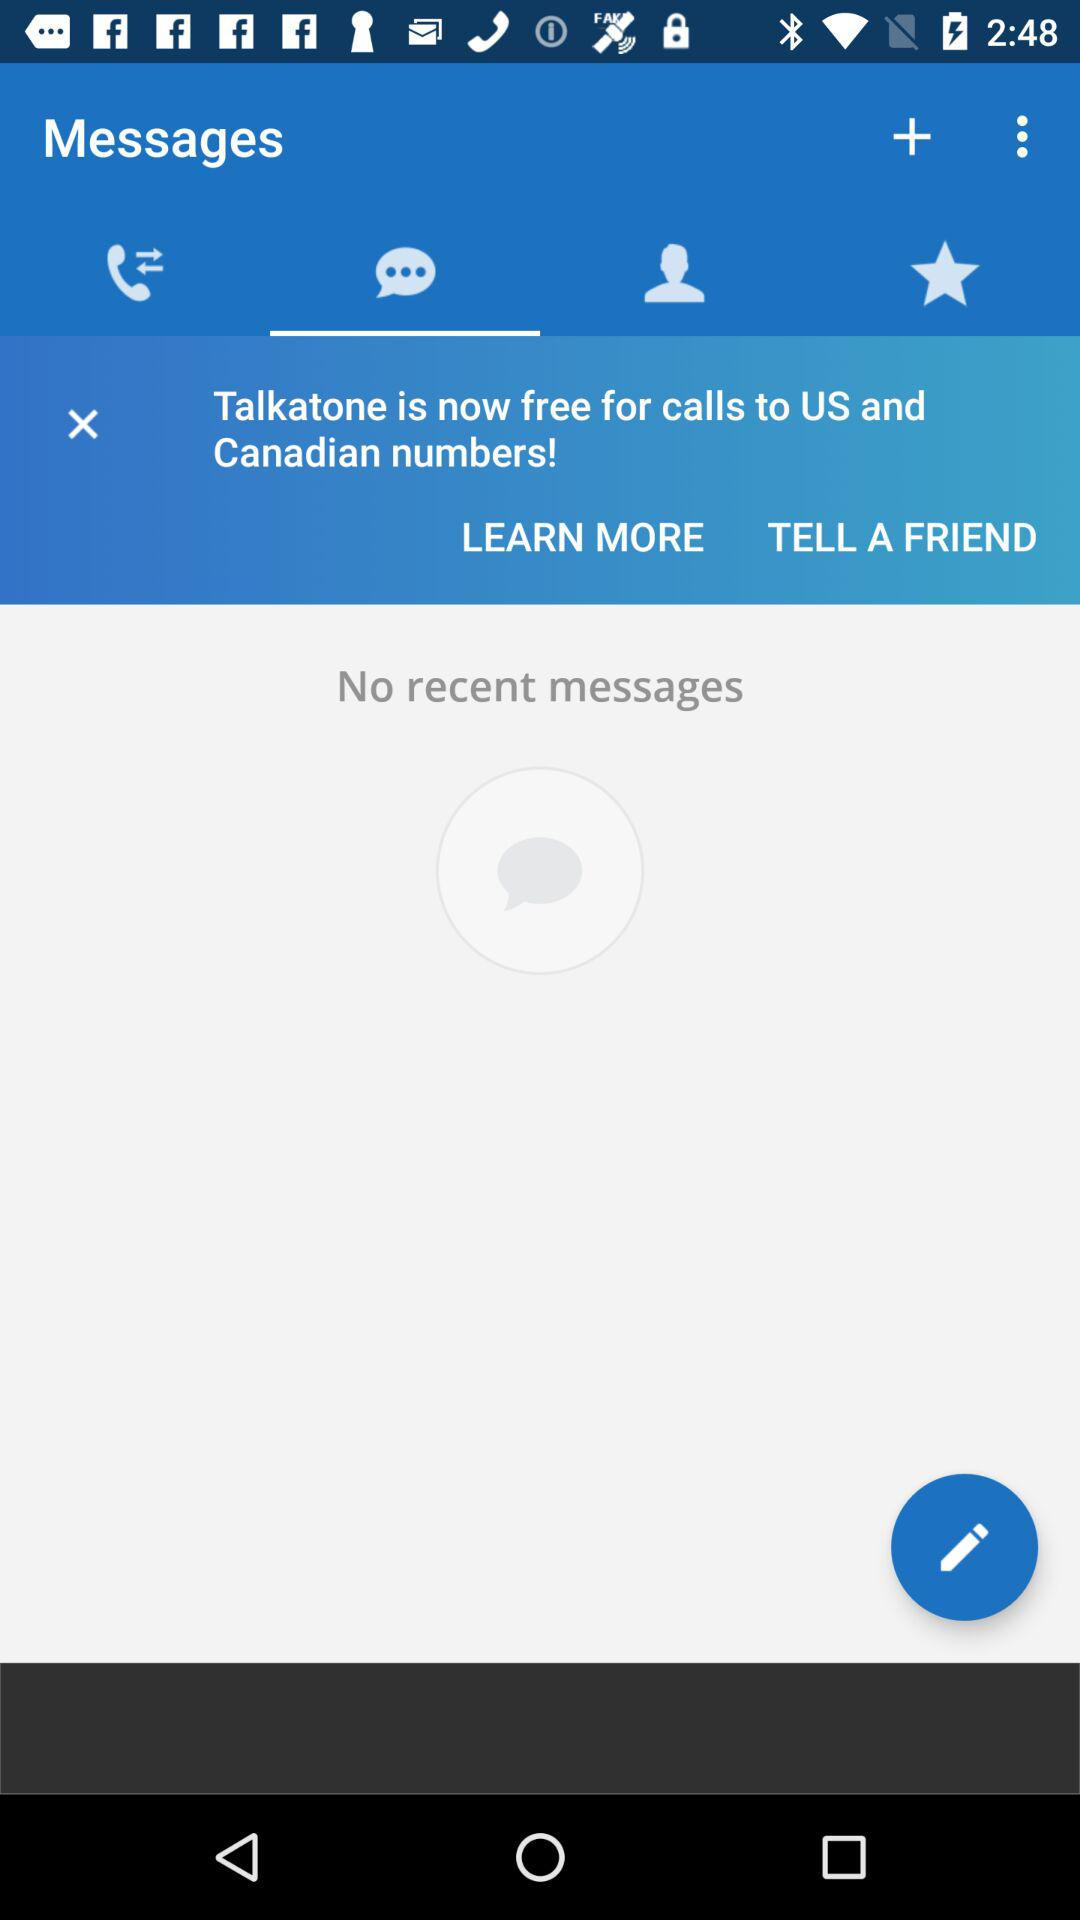Which tab is selected? The selected tab is "Messages". 